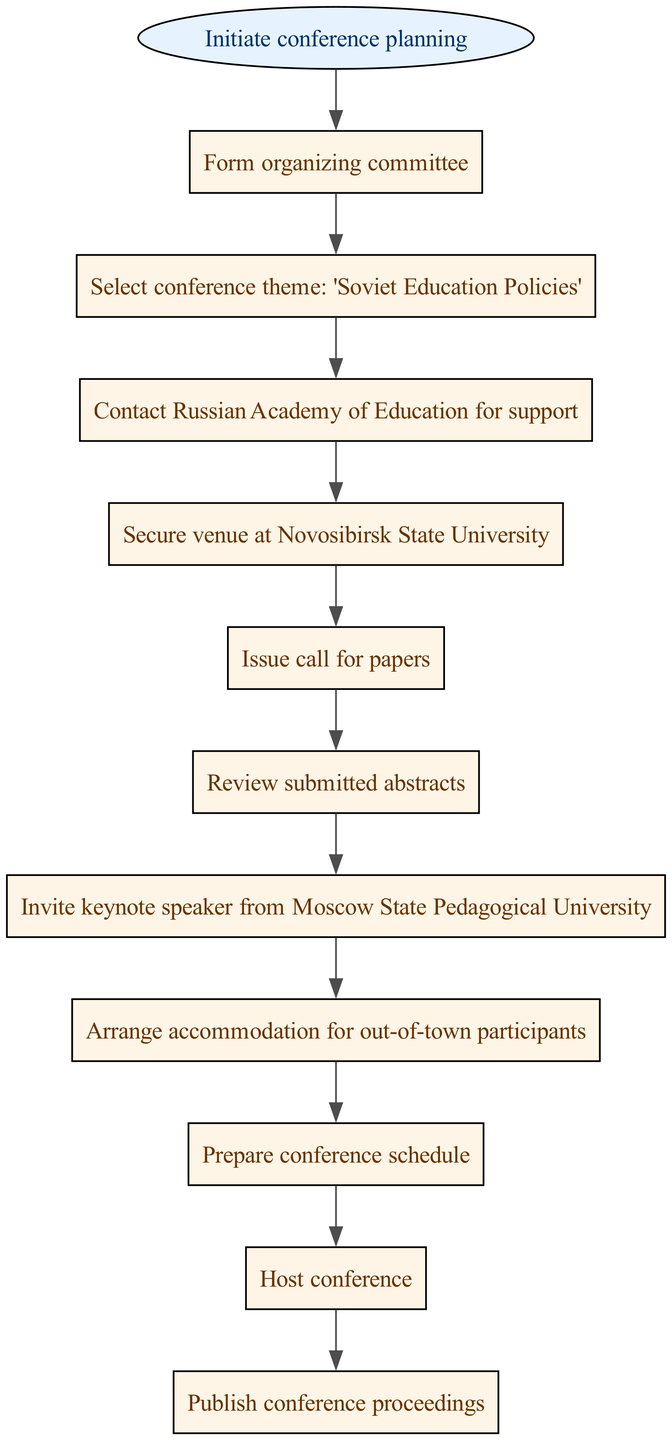What is the first step in organizing the conference? The first step is "Initiate conference planning," which is clearly indicated as the starting point in the diagram. It is the initial stage that sets off the entire flow.
Answer: Initiate conference planning How many total steps are involved in the conference planning process? By counting each distinct box in the flowchart, we see there are 10 steps before the conference concludes, including the start and end nodes.
Answer: 10 What is the final action taken after hosting the conference? The last action shown in the flowchart is "Publish conference proceedings," indicating that this is the concluding task after the event has taken place.
Answer: Publish conference proceedings Which node follows the "Review submitted abstracts" step? According to the flowchart, the step that follows "Review submitted abstracts" is "Invite keynote speaker from Moscow State Pedagogical University." This indicates the sequence of actions in organizing the conference.
Answer: Invite keynote speaker from Moscow State Pedagogical University What is the relationship between the "Select conference theme" node and the "Issue call for papers" node? In the flowchart, "Select conference theme" directly leads into "Issue call for papers," demonstrating that once the theme is established, the next logical step is to call for papers related to that theme.
Answer: Directly leads to What is the significance of contacting the Russian Academy of Education in this process? Contacting the Russian Academy of Education for support is a crucial step that signifies the importance of institutional backing and collaboration in successfully organizing the conference focused on educational policies.
Answer: Institutional backing How many nodes are dedicated to logistical arrangements, such as venue and accommodation? Examining the flowchart, there are three nodes directly related to logistical arrangements: "Secure venue at Novosibirsk State University," "Arrange accommodation for out-of-town participants," and "Prepare conference schedule." Together, these nodes focus on essential planning for the conference logistics.
Answer: 3 Which step indicates the selection of a theme for the conference? The node "Select conference theme: 'Soviet Education Policies'" clearly identifies the step dedicated to determining the overall focus of the conference, which is essential for guiding the content and discussions.
Answer: Select conference theme: 'Soviet Education Policies' 